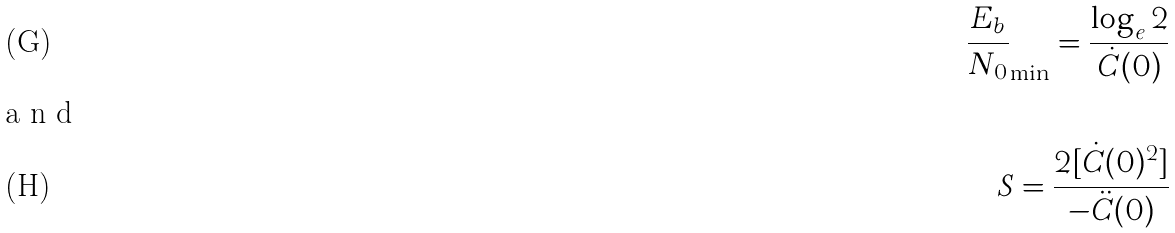<formula> <loc_0><loc_0><loc_500><loc_500>\frac { E _ { b } } { N _ { 0 } } _ { \min } = \frac { \log _ { e } 2 } { \dot { C } ( 0 ) } \\ \intertext { a n d } S = \frac { 2 [ \dot { C } ( 0 ) ^ { 2 } ] } { - \ddot { C } ( 0 ) }</formula> 